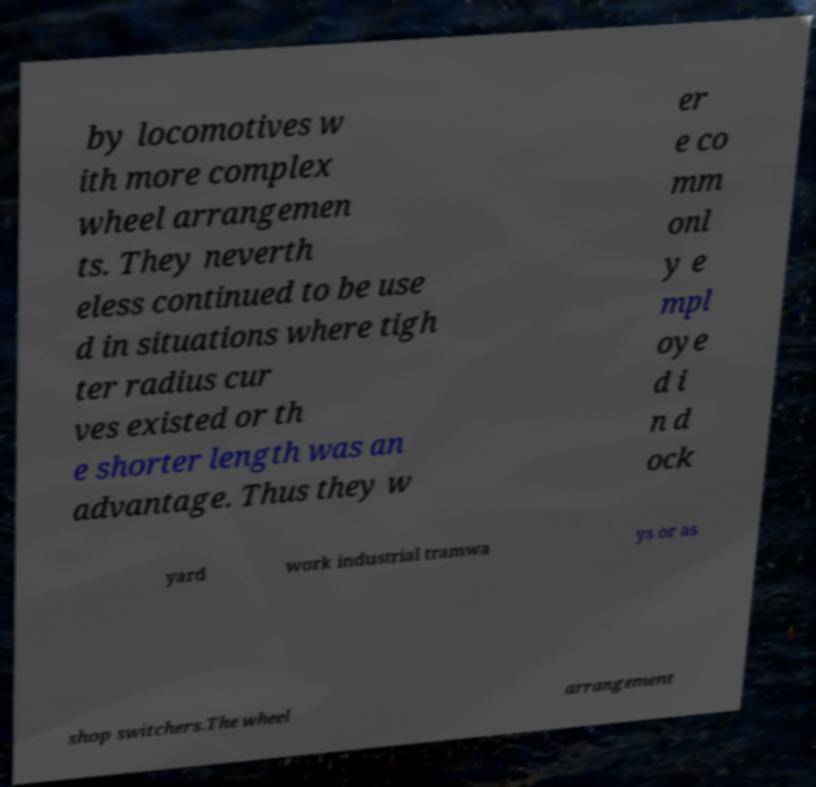For documentation purposes, I need the text within this image transcribed. Could you provide that? by locomotives w ith more complex wheel arrangemen ts. They neverth eless continued to be use d in situations where tigh ter radius cur ves existed or th e shorter length was an advantage. Thus they w er e co mm onl y e mpl oye d i n d ock yard work industrial tramwa ys or as shop switchers.The wheel arrangement 